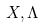<formula> <loc_0><loc_0><loc_500><loc_500>X , \Lambda</formula> 